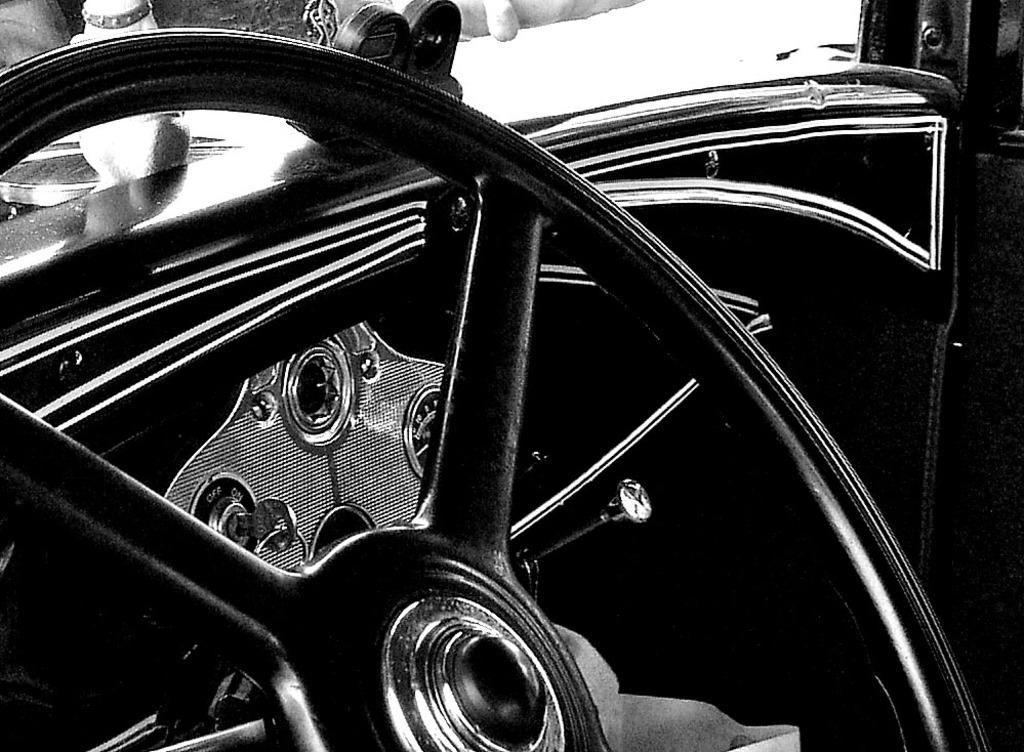What is the main object in the image? There is a steering wheel in the image. What can be seen in the background of the image? There are objects visible in the background of the image. What is the color scheme of the image? The image is in black and white. How many cherries are on the spoon in the image? There is no spoon or cherries present in the image. What act is being performed by the person holding the steering wheel in the image? There is no person visible in the image, and therefore no act being performed. 